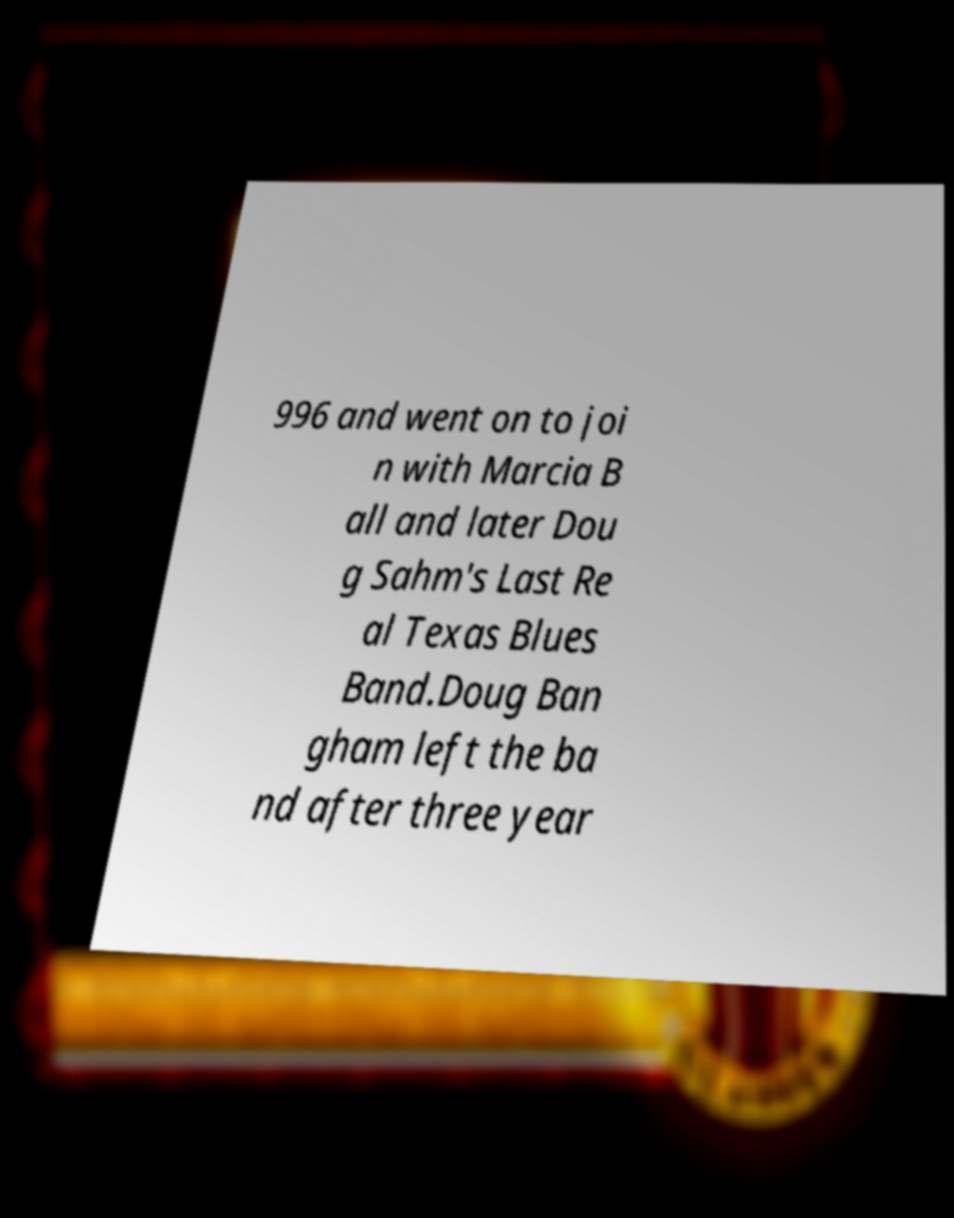Could you extract and type out the text from this image? 996 and went on to joi n with Marcia B all and later Dou g Sahm's Last Re al Texas Blues Band.Doug Ban gham left the ba nd after three year 